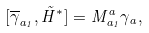<formula> <loc_0><loc_0><loc_500><loc_500>[ \overline { \gamma } _ { a _ { 1 } } , \tilde { H } ^ { * } ] = M _ { a _ { 1 } } ^ { a } \gamma _ { a } ,</formula> 